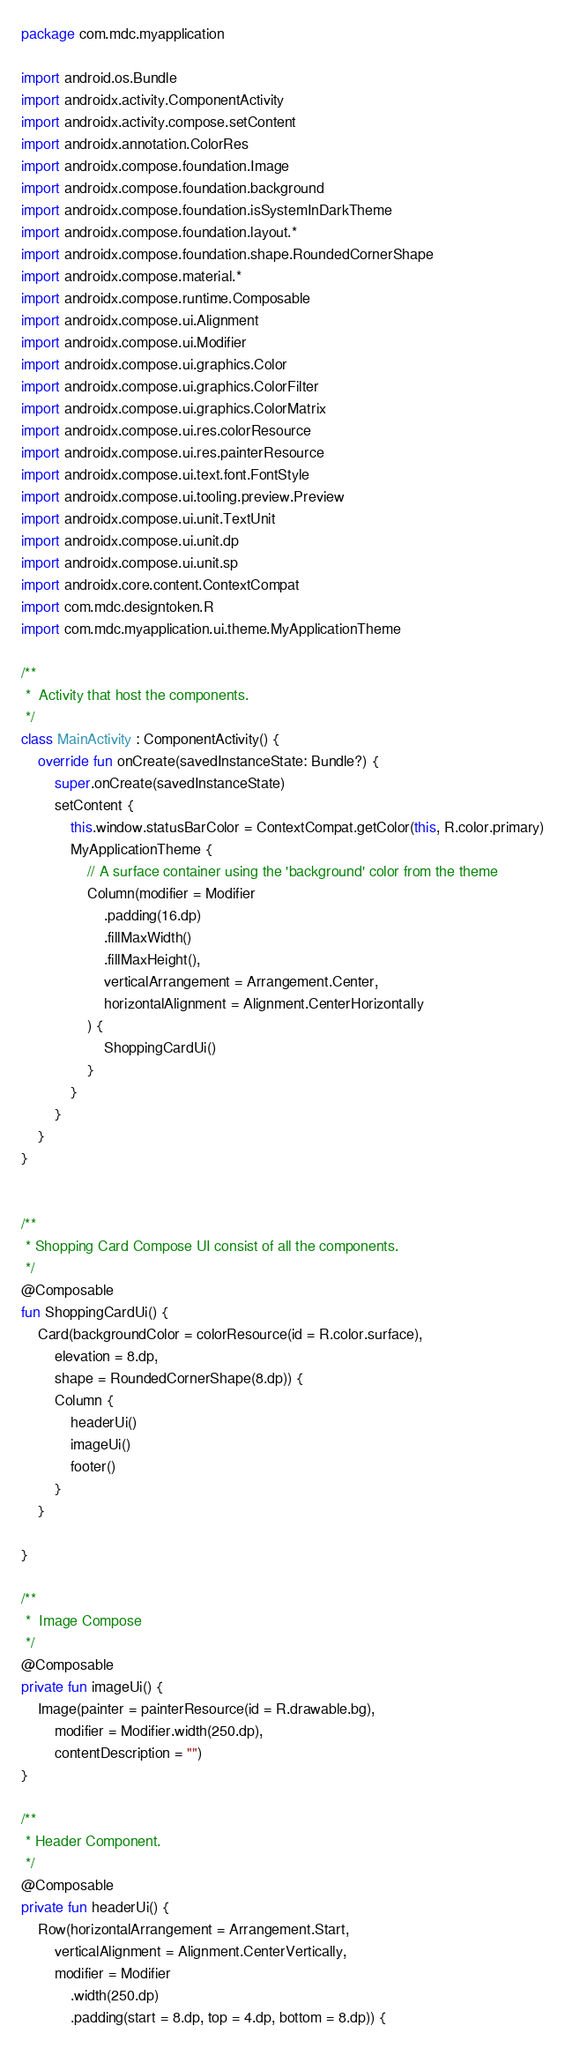Convert code to text. <code><loc_0><loc_0><loc_500><loc_500><_Kotlin_>package com.mdc.myapplication

import android.os.Bundle
import androidx.activity.ComponentActivity
import androidx.activity.compose.setContent
import androidx.annotation.ColorRes
import androidx.compose.foundation.Image
import androidx.compose.foundation.background
import androidx.compose.foundation.isSystemInDarkTheme
import androidx.compose.foundation.layout.*
import androidx.compose.foundation.shape.RoundedCornerShape
import androidx.compose.material.*
import androidx.compose.runtime.Composable
import androidx.compose.ui.Alignment
import androidx.compose.ui.Modifier
import androidx.compose.ui.graphics.Color
import androidx.compose.ui.graphics.ColorFilter
import androidx.compose.ui.graphics.ColorMatrix
import androidx.compose.ui.res.colorResource
import androidx.compose.ui.res.painterResource
import androidx.compose.ui.text.font.FontStyle
import androidx.compose.ui.tooling.preview.Preview
import androidx.compose.ui.unit.TextUnit
import androidx.compose.ui.unit.dp
import androidx.compose.ui.unit.sp
import androidx.core.content.ContextCompat
import com.mdc.designtoken.R
import com.mdc.myapplication.ui.theme.MyApplicationTheme

/**
 *  Activity that host the components.
 */
class MainActivity : ComponentActivity() {
    override fun onCreate(savedInstanceState: Bundle?) {
        super.onCreate(savedInstanceState)
        setContent {
            this.window.statusBarColor = ContextCompat.getColor(this, R.color.primary)
            MyApplicationTheme {
                // A surface container using the 'background' color from the theme
                Column(modifier = Modifier
                    .padding(16.dp)
                    .fillMaxWidth()
                    .fillMaxHeight(),
                    verticalArrangement = Arrangement.Center,
                    horizontalAlignment = Alignment.CenterHorizontally
                ) {
                    ShoppingCardUi()
                }
            }
        }
    }
}


/**
 * Shopping Card Compose UI consist of all the components.
 */
@Composable
fun ShoppingCardUi() {
    Card(backgroundColor = colorResource(id = R.color.surface),
        elevation = 8.dp,
        shape = RoundedCornerShape(8.dp)) {
        Column {
            headerUi()
            imageUi()
            footer()
        }
    }

}

/**
 *  Image Compose
 */
@Composable
private fun imageUi() {
    Image(painter = painterResource(id = R.drawable.bg),
        modifier = Modifier.width(250.dp),
        contentDescription = "")
}

/**
 * Header Component.
 */
@Composable
private fun headerUi() {
    Row(horizontalArrangement = Arrangement.Start,
        verticalAlignment = Alignment.CenterVertically,
        modifier = Modifier
            .width(250.dp)
            .padding(start = 8.dp, top = 4.dp, bottom = 8.dp)) {</code> 